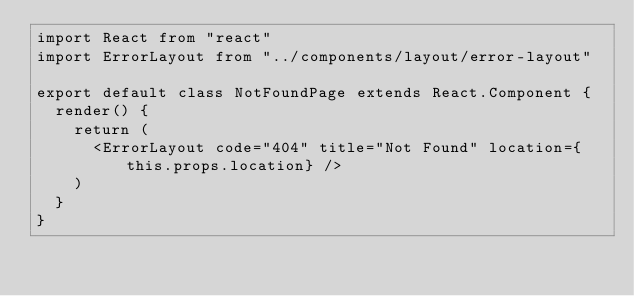<code> <loc_0><loc_0><loc_500><loc_500><_JavaScript_>import React from "react"
import ErrorLayout from "../components/layout/error-layout"

export default class NotFoundPage extends React.Component {
  render() {
    return (
      <ErrorLayout code="404" title="Not Found" location={this.props.location} />
    )
  }
}
</code> 